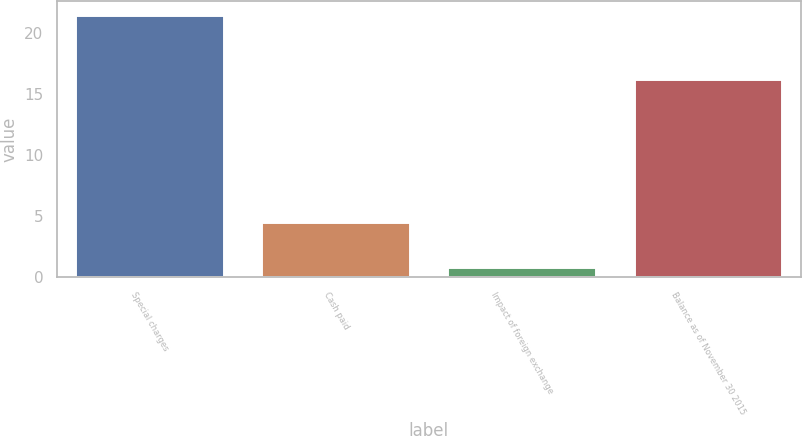Convert chart. <chart><loc_0><loc_0><loc_500><loc_500><bar_chart><fcel>Special charges<fcel>Cash paid<fcel>Impact of foreign exchange<fcel>Balance as of November 30 2015<nl><fcel>21.5<fcel>4.5<fcel>0.8<fcel>16.2<nl></chart> 